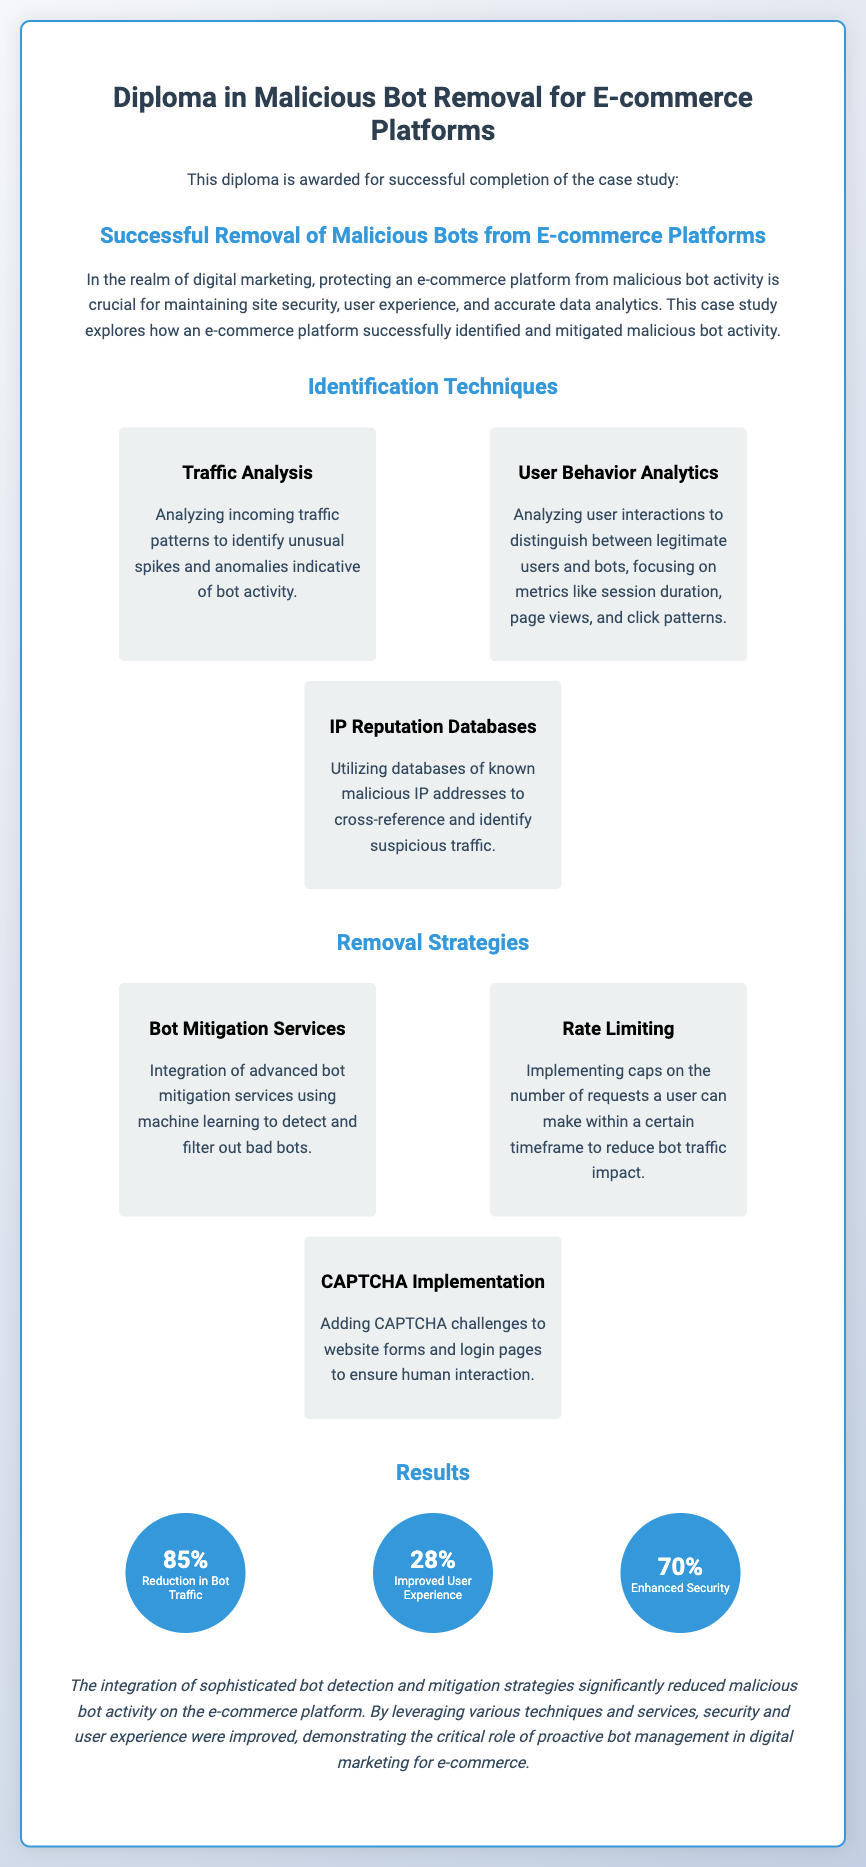What is the title of the diploma? The title of the diploma is indicated prominently at the top of the document.
Answer: Diploma in Malicious Bot Removal for E-commerce Platforms How much was the reduction in bot traffic? The document states the percentage reduction in bot traffic under the results section.
Answer: 85% What technique involves analyzing user interactions? The technique that focuses on analyzing user interactions is mentioned in the identification techniques section.
Answer: User Behavior Analytics What is one of the removal strategies mentioned? The document lists various removal strategies under a dedicated section.
Answer: CAPTCHA Implementation What percentage improvement was noted in user experience? The document provides a specific metric related to user experience improvements in the results section.
Answer: 28% Which tool is suggested for identifying malicious IP addresses? The document discusses a specific technique for identifying suspicious traffic under the identification techniques section.
Answer: IP Reputation Databases What impact did the strategies have on security? The enhancement in security is quantified in the results section.
Answer: 70% What is one method used to reduce bot traffic impact? The document lists methods employed to mitigate bot traffic in the removal strategies section.
Answer: Rate Limiting What is the overall conclusion drawn about bot management? The conclusion summarizes the outcomes of implementing the strategies discussed in the document.
Answer: Improved security and user experience 